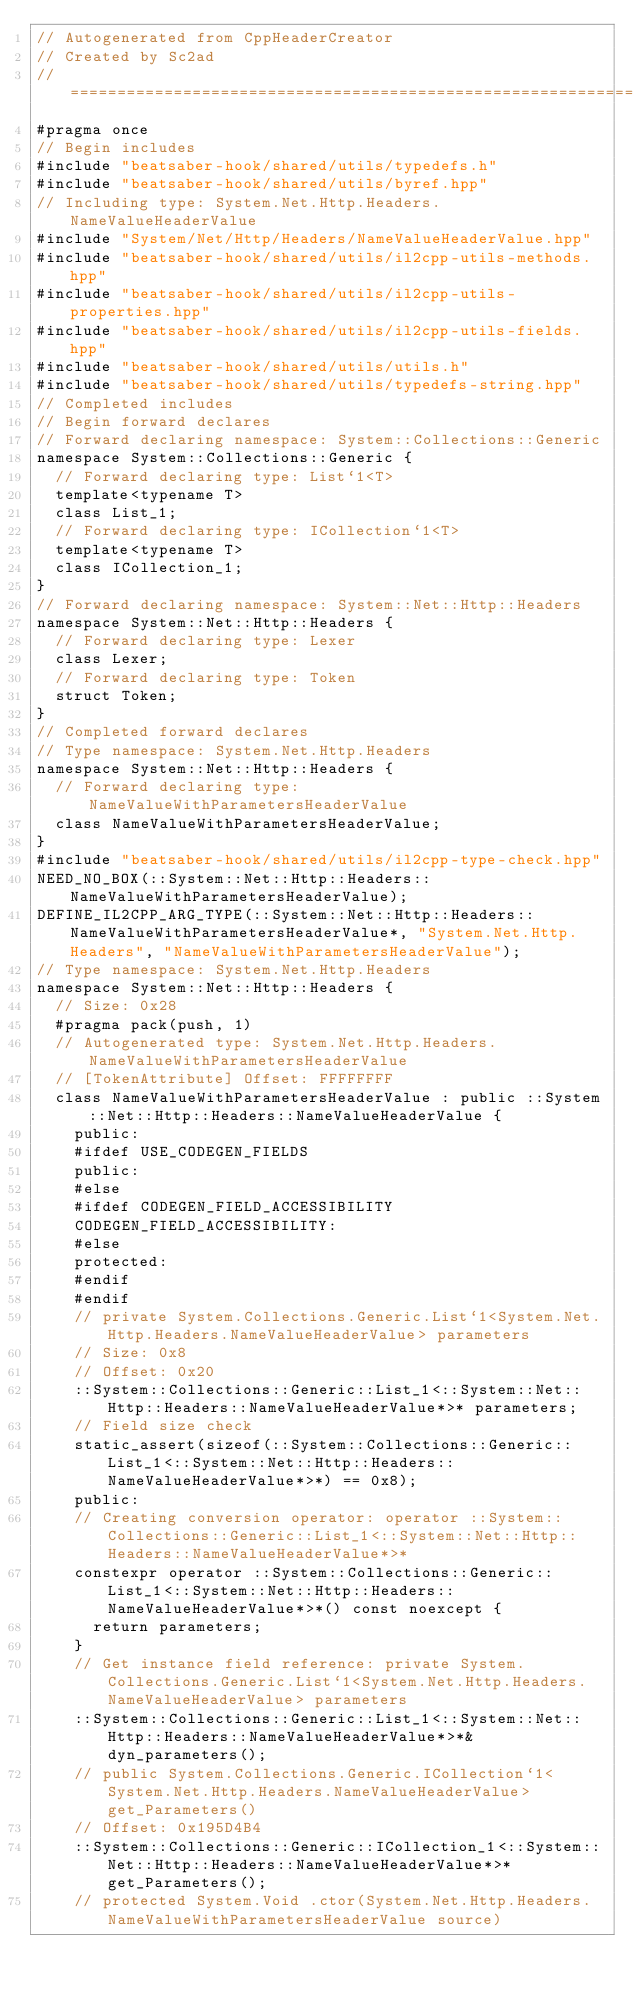<code> <loc_0><loc_0><loc_500><loc_500><_C++_>// Autogenerated from CppHeaderCreator
// Created by Sc2ad
// =========================================================================
#pragma once
// Begin includes
#include "beatsaber-hook/shared/utils/typedefs.h"
#include "beatsaber-hook/shared/utils/byref.hpp"
// Including type: System.Net.Http.Headers.NameValueHeaderValue
#include "System/Net/Http/Headers/NameValueHeaderValue.hpp"
#include "beatsaber-hook/shared/utils/il2cpp-utils-methods.hpp"
#include "beatsaber-hook/shared/utils/il2cpp-utils-properties.hpp"
#include "beatsaber-hook/shared/utils/il2cpp-utils-fields.hpp"
#include "beatsaber-hook/shared/utils/utils.h"
#include "beatsaber-hook/shared/utils/typedefs-string.hpp"
// Completed includes
// Begin forward declares
// Forward declaring namespace: System::Collections::Generic
namespace System::Collections::Generic {
  // Forward declaring type: List`1<T>
  template<typename T>
  class List_1;
  // Forward declaring type: ICollection`1<T>
  template<typename T>
  class ICollection_1;
}
// Forward declaring namespace: System::Net::Http::Headers
namespace System::Net::Http::Headers {
  // Forward declaring type: Lexer
  class Lexer;
  // Forward declaring type: Token
  struct Token;
}
// Completed forward declares
// Type namespace: System.Net.Http.Headers
namespace System::Net::Http::Headers {
  // Forward declaring type: NameValueWithParametersHeaderValue
  class NameValueWithParametersHeaderValue;
}
#include "beatsaber-hook/shared/utils/il2cpp-type-check.hpp"
NEED_NO_BOX(::System::Net::Http::Headers::NameValueWithParametersHeaderValue);
DEFINE_IL2CPP_ARG_TYPE(::System::Net::Http::Headers::NameValueWithParametersHeaderValue*, "System.Net.Http.Headers", "NameValueWithParametersHeaderValue");
// Type namespace: System.Net.Http.Headers
namespace System::Net::Http::Headers {
  // Size: 0x28
  #pragma pack(push, 1)
  // Autogenerated type: System.Net.Http.Headers.NameValueWithParametersHeaderValue
  // [TokenAttribute] Offset: FFFFFFFF
  class NameValueWithParametersHeaderValue : public ::System::Net::Http::Headers::NameValueHeaderValue {
    public:
    #ifdef USE_CODEGEN_FIELDS
    public:
    #else
    #ifdef CODEGEN_FIELD_ACCESSIBILITY
    CODEGEN_FIELD_ACCESSIBILITY:
    #else
    protected:
    #endif
    #endif
    // private System.Collections.Generic.List`1<System.Net.Http.Headers.NameValueHeaderValue> parameters
    // Size: 0x8
    // Offset: 0x20
    ::System::Collections::Generic::List_1<::System::Net::Http::Headers::NameValueHeaderValue*>* parameters;
    // Field size check
    static_assert(sizeof(::System::Collections::Generic::List_1<::System::Net::Http::Headers::NameValueHeaderValue*>*) == 0x8);
    public:
    // Creating conversion operator: operator ::System::Collections::Generic::List_1<::System::Net::Http::Headers::NameValueHeaderValue*>*
    constexpr operator ::System::Collections::Generic::List_1<::System::Net::Http::Headers::NameValueHeaderValue*>*() const noexcept {
      return parameters;
    }
    // Get instance field reference: private System.Collections.Generic.List`1<System.Net.Http.Headers.NameValueHeaderValue> parameters
    ::System::Collections::Generic::List_1<::System::Net::Http::Headers::NameValueHeaderValue*>*& dyn_parameters();
    // public System.Collections.Generic.ICollection`1<System.Net.Http.Headers.NameValueHeaderValue> get_Parameters()
    // Offset: 0x195D4B4
    ::System::Collections::Generic::ICollection_1<::System::Net::Http::Headers::NameValueHeaderValue*>* get_Parameters();
    // protected System.Void .ctor(System.Net.Http.Headers.NameValueWithParametersHeaderValue source)</code> 